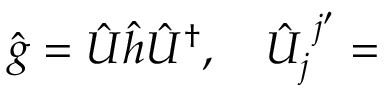<formula> <loc_0><loc_0><loc_500><loc_500>\hat { g } = \hat { U } \hat { h } \hat { U } ^ { \dagger } , \quad \hat { U } _ { j } ^ { \, j ^ { \prime } } =</formula> 